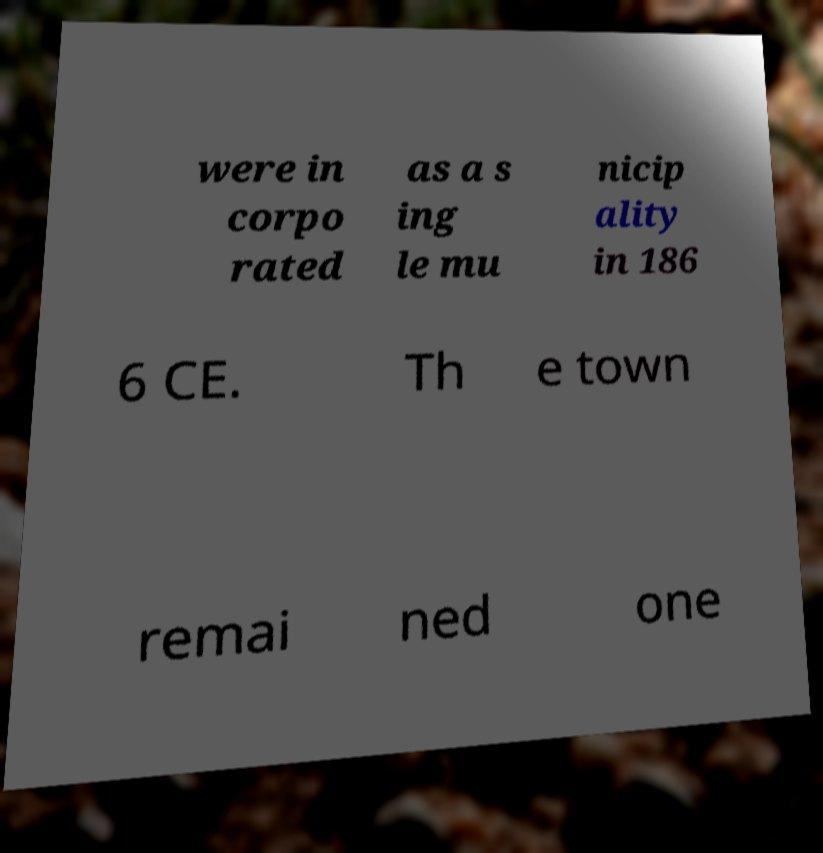Could you assist in decoding the text presented in this image and type it out clearly? were in corpo rated as a s ing le mu nicip ality in 186 6 CE. Th e town remai ned one 